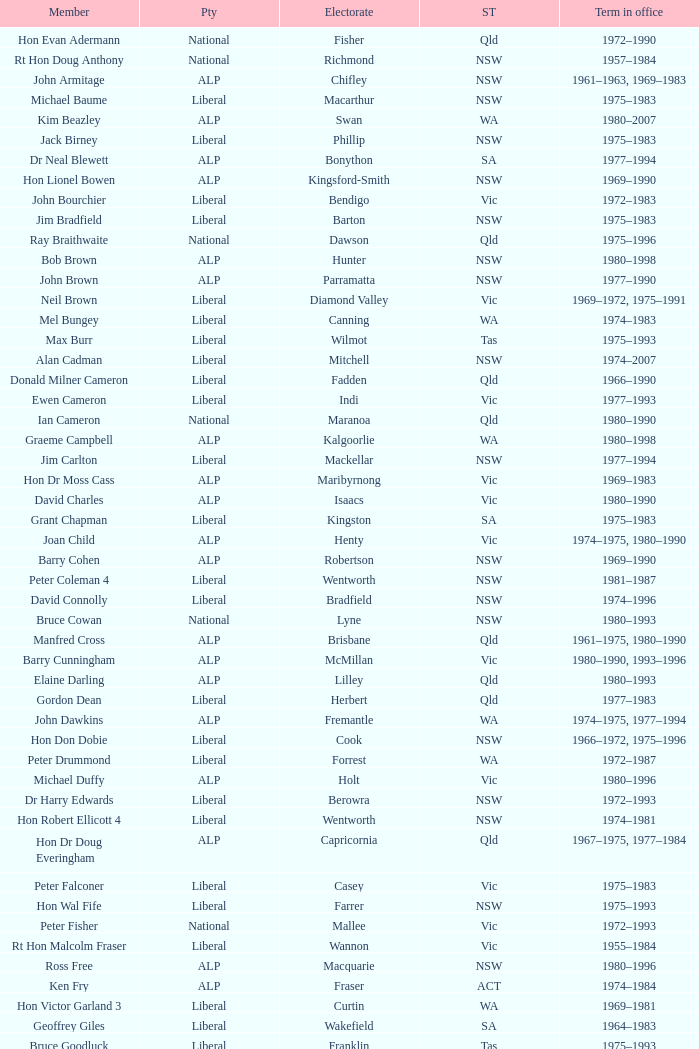Which party had a member from the state of Vic and an Electorate called Wannon? Liberal. 